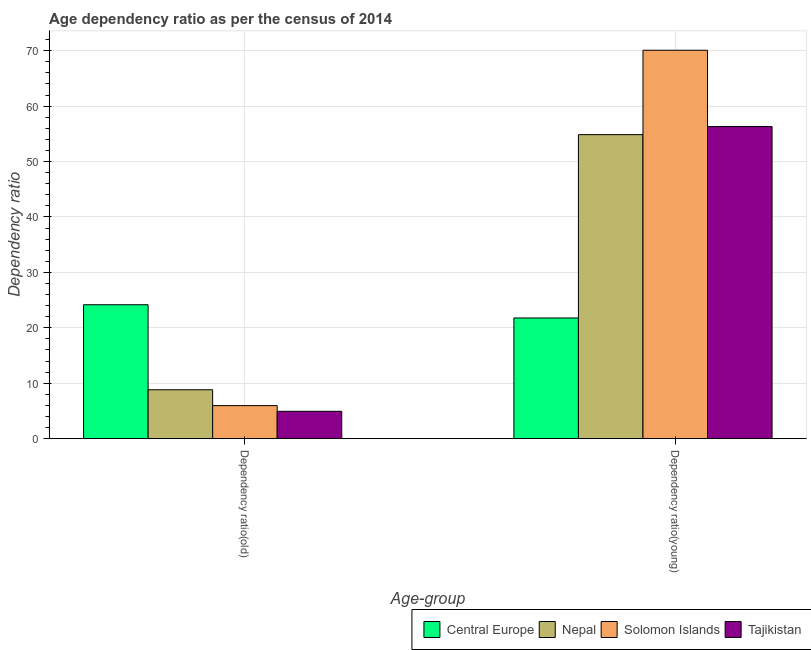How many groups of bars are there?
Ensure brevity in your answer.  2. Are the number of bars per tick equal to the number of legend labels?
Your response must be concise. Yes. How many bars are there on the 2nd tick from the right?
Make the answer very short. 4. What is the label of the 2nd group of bars from the left?
Ensure brevity in your answer.  Dependency ratio(young). What is the age dependency ratio(young) in Tajikistan?
Your answer should be compact. 56.32. Across all countries, what is the maximum age dependency ratio(young)?
Keep it short and to the point. 70.09. Across all countries, what is the minimum age dependency ratio(old)?
Give a very brief answer. 4.93. In which country was the age dependency ratio(old) maximum?
Provide a short and direct response. Central Europe. In which country was the age dependency ratio(old) minimum?
Give a very brief answer. Tajikistan. What is the total age dependency ratio(young) in the graph?
Your response must be concise. 203.03. What is the difference between the age dependency ratio(old) in Central Europe and that in Nepal?
Your answer should be compact. 15.34. What is the difference between the age dependency ratio(old) in Solomon Islands and the age dependency ratio(young) in Nepal?
Make the answer very short. -48.9. What is the average age dependency ratio(young) per country?
Offer a very short reply. 50.76. What is the difference between the age dependency ratio(young) and age dependency ratio(old) in Central Europe?
Keep it short and to the point. -2.39. What is the ratio of the age dependency ratio(old) in Central Europe to that in Nepal?
Offer a terse response. 2.74. Is the age dependency ratio(old) in Central Europe less than that in Tajikistan?
Your answer should be compact. No. In how many countries, is the age dependency ratio(old) greater than the average age dependency ratio(old) taken over all countries?
Provide a short and direct response. 1. What does the 2nd bar from the left in Dependency ratio(old) represents?
Give a very brief answer. Nepal. What does the 3rd bar from the right in Dependency ratio(old) represents?
Provide a short and direct response. Nepal. Are all the bars in the graph horizontal?
Offer a terse response. No. How many countries are there in the graph?
Your answer should be very brief. 4. What is the difference between two consecutive major ticks on the Y-axis?
Your response must be concise. 10. Are the values on the major ticks of Y-axis written in scientific E-notation?
Your answer should be very brief. No. Does the graph contain any zero values?
Your answer should be very brief. No. Does the graph contain grids?
Ensure brevity in your answer.  Yes. How many legend labels are there?
Your answer should be very brief. 4. What is the title of the graph?
Provide a short and direct response. Age dependency ratio as per the census of 2014. What is the label or title of the X-axis?
Provide a succinct answer. Age-group. What is the label or title of the Y-axis?
Make the answer very short. Dependency ratio. What is the Dependency ratio of Central Europe in Dependency ratio(old)?
Give a very brief answer. 24.16. What is the Dependency ratio in Nepal in Dependency ratio(old)?
Your answer should be compact. 8.82. What is the Dependency ratio in Solomon Islands in Dependency ratio(old)?
Make the answer very short. 5.96. What is the Dependency ratio in Tajikistan in Dependency ratio(old)?
Keep it short and to the point. 4.93. What is the Dependency ratio of Central Europe in Dependency ratio(young)?
Offer a very short reply. 21.77. What is the Dependency ratio of Nepal in Dependency ratio(young)?
Keep it short and to the point. 54.86. What is the Dependency ratio in Solomon Islands in Dependency ratio(young)?
Provide a short and direct response. 70.09. What is the Dependency ratio in Tajikistan in Dependency ratio(young)?
Provide a short and direct response. 56.32. Across all Age-group, what is the maximum Dependency ratio in Central Europe?
Offer a terse response. 24.16. Across all Age-group, what is the maximum Dependency ratio in Nepal?
Offer a very short reply. 54.86. Across all Age-group, what is the maximum Dependency ratio in Solomon Islands?
Give a very brief answer. 70.09. Across all Age-group, what is the maximum Dependency ratio in Tajikistan?
Provide a short and direct response. 56.32. Across all Age-group, what is the minimum Dependency ratio in Central Europe?
Ensure brevity in your answer.  21.77. Across all Age-group, what is the minimum Dependency ratio of Nepal?
Make the answer very short. 8.82. Across all Age-group, what is the minimum Dependency ratio in Solomon Islands?
Provide a succinct answer. 5.96. Across all Age-group, what is the minimum Dependency ratio of Tajikistan?
Provide a short and direct response. 4.93. What is the total Dependency ratio of Central Europe in the graph?
Make the answer very short. 45.93. What is the total Dependency ratio in Nepal in the graph?
Make the answer very short. 63.68. What is the total Dependency ratio of Solomon Islands in the graph?
Your answer should be very brief. 76.04. What is the total Dependency ratio of Tajikistan in the graph?
Give a very brief answer. 61.24. What is the difference between the Dependency ratio of Central Europe in Dependency ratio(old) and that in Dependency ratio(young)?
Provide a succinct answer. 2.39. What is the difference between the Dependency ratio in Nepal in Dependency ratio(old) and that in Dependency ratio(young)?
Offer a very short reply. -46.04. What is the difference between the Dependency ratio of Solomon Islands in Dependency ratio(old) and that in Dependency ratio(young)?
Provide a short and direct response. -64.13. What is the difference between the Dependency ratio in Tajikistan in Dependency ratio(old) and that in Dependency ratio(young)?
Offer a very short reply. -51.39. What is the difference between the Dependency ratio in Central Europe in Dependency ratio(old) and the Dependency ratio in Nepal in Dependency ratio(young)?
Ensure brevity in your answer.  -30.7. What is the difference between the Dependency ratio of Central Europe in Dependency ratio(old) and the Dependency ratio of Solomon Islands in Dependency ratio(young)?
Make the answer very short. -45.93. What is the difference between the Dependency ratio in Central Europe in Dependency ratio(old) and the Dependency ratio in Tajikistan in Dependency ratio(young)?
Make the answer very short. -32.16. What is the difference between the Dependency ratio in Nepal in Dependency ratio(old) and the Dependency ratio in Solomon Islands in Dependency ratio(young)?
Provide a short and direct response. -61.27. What is the difference between the Dependency ratio in Nepal in Dependency ratio(old) and the Dependency ratio in Tajikistan in Dependency ratio(young)?
Keep it short and to the point. -47.5. What is the difference between the Dependency ratio in Solomon Islands in Dependency ratio(old) and the Dependency ratio in Tajikistan in Dependency ratio(young)?
Ensure brevity in your answer.  -50.36. What is the average Dependency ratio in Central Europe per Age-group?
Offer a very short reply. 22.97. What is the average Dependency ratio in Nepal per Age-group?
Offer a very short reply. 31.84. What is the average Dependency ratio of Solomon Islands per Age-group?
Ensure brevity in your answer.  38.02. What is the average Dependency ratio of Tajikistan per Age-group?
Offer a terse response. 30.62. What is the difference between the Dependency ratio in Central Europe and Dependency ratio in Nepal in Dependency ratio(old)?
Your response must be concise. 15.34. What is the difference between the Dependency ratio of Central Europe and Dependency ratio of Solomon Islands in Dependency ratio(old)?
Give a very brief answer. 18.2. What is the difference between the Dependency ratio in Central Europe and Dependency ratio in Tajikistan in Dependency ratio(old)?
Give a very brief answer. 19.23. What is the difference between the Dependency ratio of Nepal and Dependency ratio of Solomon Islands in Dependency ratio(old)?
Ensure brevity in your answer.  2.86. What is the difference between the Dependency ratio in Nepal and Dependency ratio in Tajikistan in Dependency ratio(old)?
Offer a very short reply. 3.89. What is the difference between the Dependency ratio in Solomon Islands and Dependency ratio in Tajikistan in Dependency ratio(old)?
Provide a succinct answer. 1.03. What is the difference between the Dependency ratio in Central Europe and Dependency ratio in Nepal in Dependency ratio(young)?
Offer a terse response. -33.08. What is the difference between the Dependency ratio in Central Europe and Dependency ratio in Solomon Islands in Dependency ratio(young)?
Give a very brief answer. -48.32. What is the difference between the Dependency ratio in Central Europe and Dependency ratio in Tajikistan in Dependency ratio(young)?
Make the answer very short. -34.54. What is the difference between the Dependency ratio in Nepal and Dependency ratio in Solomon Islands in Dependency ratio(young)?
Provide a succinct answer. -15.23. What is the difference between the Dependency ratio in Nepal and Dependency ratio in Tajikistan in Dependency ratio(young)?
Make the answer very short. -1.46. What is the difference between the Dependency ratio in Solomon Islands and Dependency ratio in Tajikistan in Dependency ratio(young)?
Provide a succinct answer. 13.77. What is the ratio of the Dependency ratio in Central Europe in Dependency ratio(old) to that in Dependency ratio(young)?
Provide a succinct answer. 1.11. What is the ratio of the Dependency ratio in Nepal in Dependency ratio(old) to that in Dependency ratio(young)?
Provide a succinct answer. 0.16. What is the ratio of the Dependency ratio in Solomon Islands in Dependency ratio(old) to that in Dependency ratio(young)?
Give a very brief answer. 0.09. What is the ratio of the Dependency ratio in Tajikistan in Dependency ratio(old) to that in Dependency ratio(young)?
Provide a short and direct response. 0.09. What is the difference between the highest and the second highest Dependency ratio of Central Europe?
Keep it short and to the point. 2.39. What is the difference between the highest and the second highest Dependency ratio of Nepal?
Offer a terse response. 46.04. What is the difference between the highest and the second highest Dependency ratio in Solomon Islands?
Make the answer very short. 64.13. What is the difference between the highest and the second highest Dependency ratio of Tajikistan?
Give a very brief answer. 51.39. What is the difference between the highest and the lowest Dependency ratio in Central Europe?
Offer a very short reply. 2.39. What is the difference between the highest and the lowest Dependency ratio of Nepal?
Provide a succinct answer. 46.04. What is the difference between the highest and the lowest Dependency ratio of Solomon Islands?
Your answer should be very brief. 64.13. What is the difference between the highest and the lowest Dependency ratio in Tajikistan?
Your answer should be compact. 51.39. 